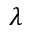Convert formula to latex. <formula><loc_0><loc_0><loc_500><loc_500>\lambda</formula> 